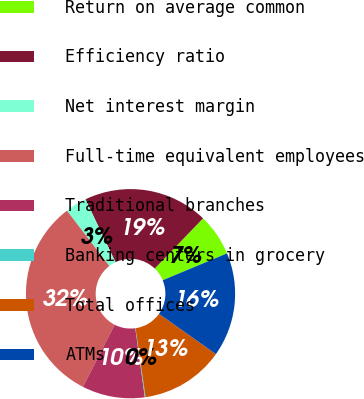Convert chart. <chart><loc_0><loc_0><loc_500><loc_500><pie_chart><fcel>Return on average common<fcel>Efficiency ratio<fcel>Net interest margin<fcel>Full-time equivalent employees<fcel>Traditional branches<fcel>Banking centers in grocery<fcel>Total offices<fcel>ATMs<nl><fcel>6.51%<fcel>19.29%<fcel>3.31%<fcel>32.08%<fcel>9.7%<fcel>0.11%<fcel>12.9%<fcel>16.1%<nl></chart> 